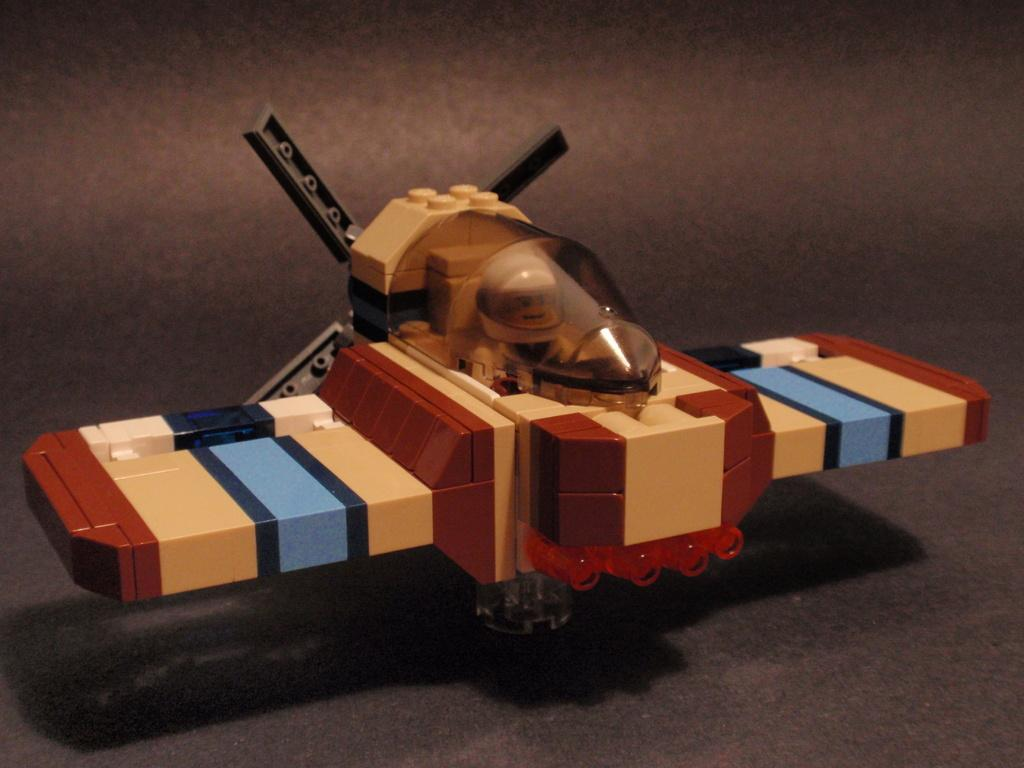What can be seen in the image? There is a toy in the image. Where is the toy located? The toy is placed on an object. What type of plantation is visible in the image? There is no plantation present in the image; it features a toy placed on an object. Can you tell me how many cacti are in the image? There are no cacti present in the image; it features a toy placed on an object. 